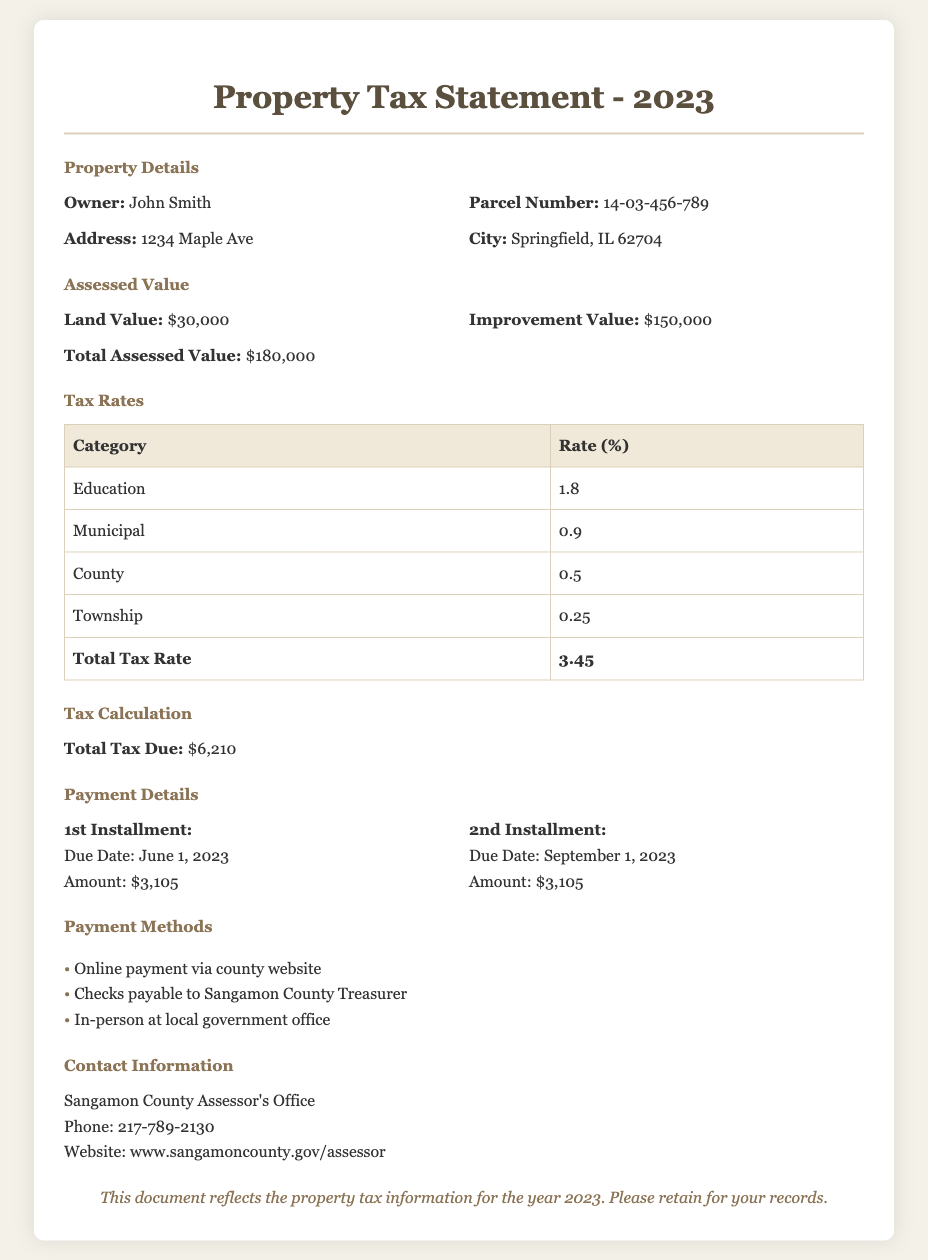what is the owner's name? The owner's name is listed in the property details section of the document, which is John Smith.
Answer: John Smith what is the total assessed value? The total assessed value is calculated from land value and improvement value, which is $30,000 + $150,000 = $180,000.
Answer: $180,000 what is the total tax due? The total tax due is mentioned in the tax calculation section, which states the amount as $6,210.
Answer: $6,210 when is the first installment due? The due date for the first installment is shown in the payment details section, which is June 1, 2023.
Answer: June 1, 2023 what is the total tax rate? The total tax rate is provided in the tax rates table, which sums to 3.45%.
Answer: 3.45 what is the land value? The land value is specified in the assessed value section, which is $30,000.
Answer: $30,000 how can you make the payment? The payment methods listed in the document provide options for payment, including online payment, checks, and in-person.
Answer: Online payment, checks, in-person what is the due date for the second installment? The due date for the second installment is mentioned in the payment details, which is September 1, 2023.
Answer: September 1, 2023 who can you contact for more information? The contact information section provides the office to reach out to, which is the Sangamon County Assessor's Office.
Answer: Sangamon County Assessor's Office 